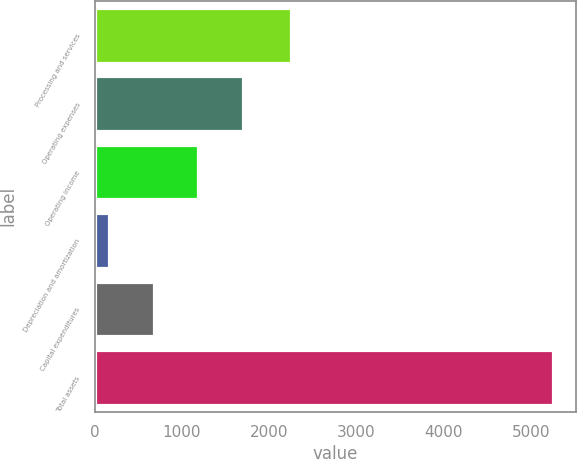Convert chart to OTSL. <chart><loc_0><loc_0><loc_500><loc_500><bar_chart><fcel>Processing and services<fcel>Operating expenses<fcel>Operating income<fcel>Depreciation and amortization<fcel>Capital expenditures<fcel>Total assets<nl><fcel>2246.4<fcel>1694.4<fcel>1185.6<fcel>168<fcel>676.8<fcel>5256<nl></chart> 